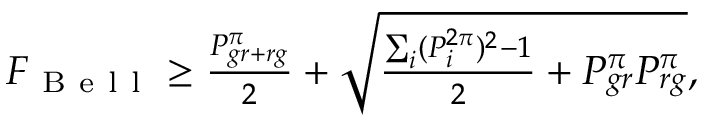<formula> <loc_0><loc_0><loc_500><loc_500>\begin{array} { r } { F _ { B e l l } \geq \frac { P _ { g r + r g } ^ { \pi } } { 2 } + \sqrt { \frac { \sum _ { i } ( P _ { i } ^ { 2 \pi } ) ^ { 2 } - 1 } { 2 } + P _ { g r } ^ { \pi } P _ { r g } ^ { \pi } } , } \end{array}</formula> 